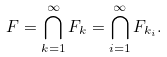<formula> <loc_0><loc_0><loc_500><loc_500>F = \bigcap _ { k = 1 } ^ { \infty } F _ { k } = \bigcap _ { i = 1 } ^ { \infty } F _ { k _ { i } } .</formula> 